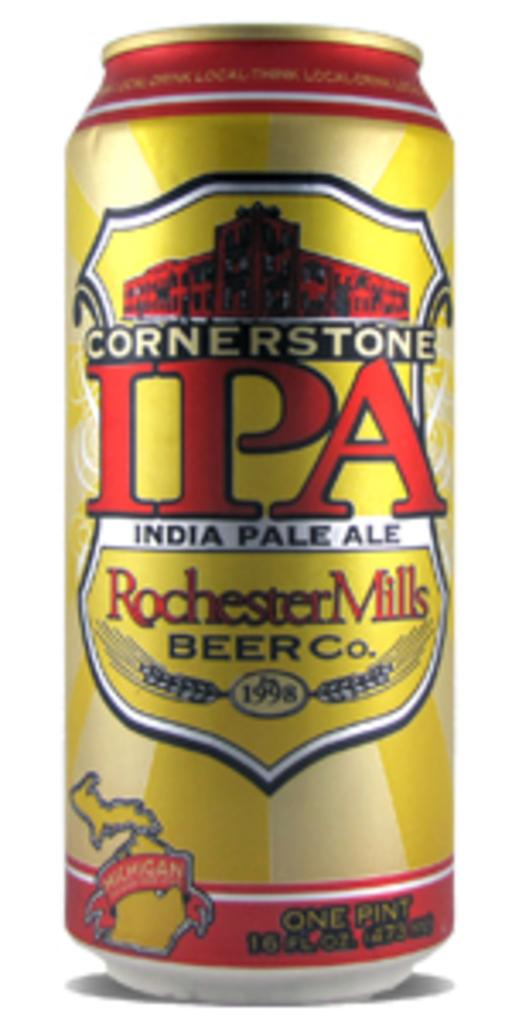Provide a one-sentence caption for the provided image. A can of Cornerstone IPA by Rochester Mills Beer Company. 